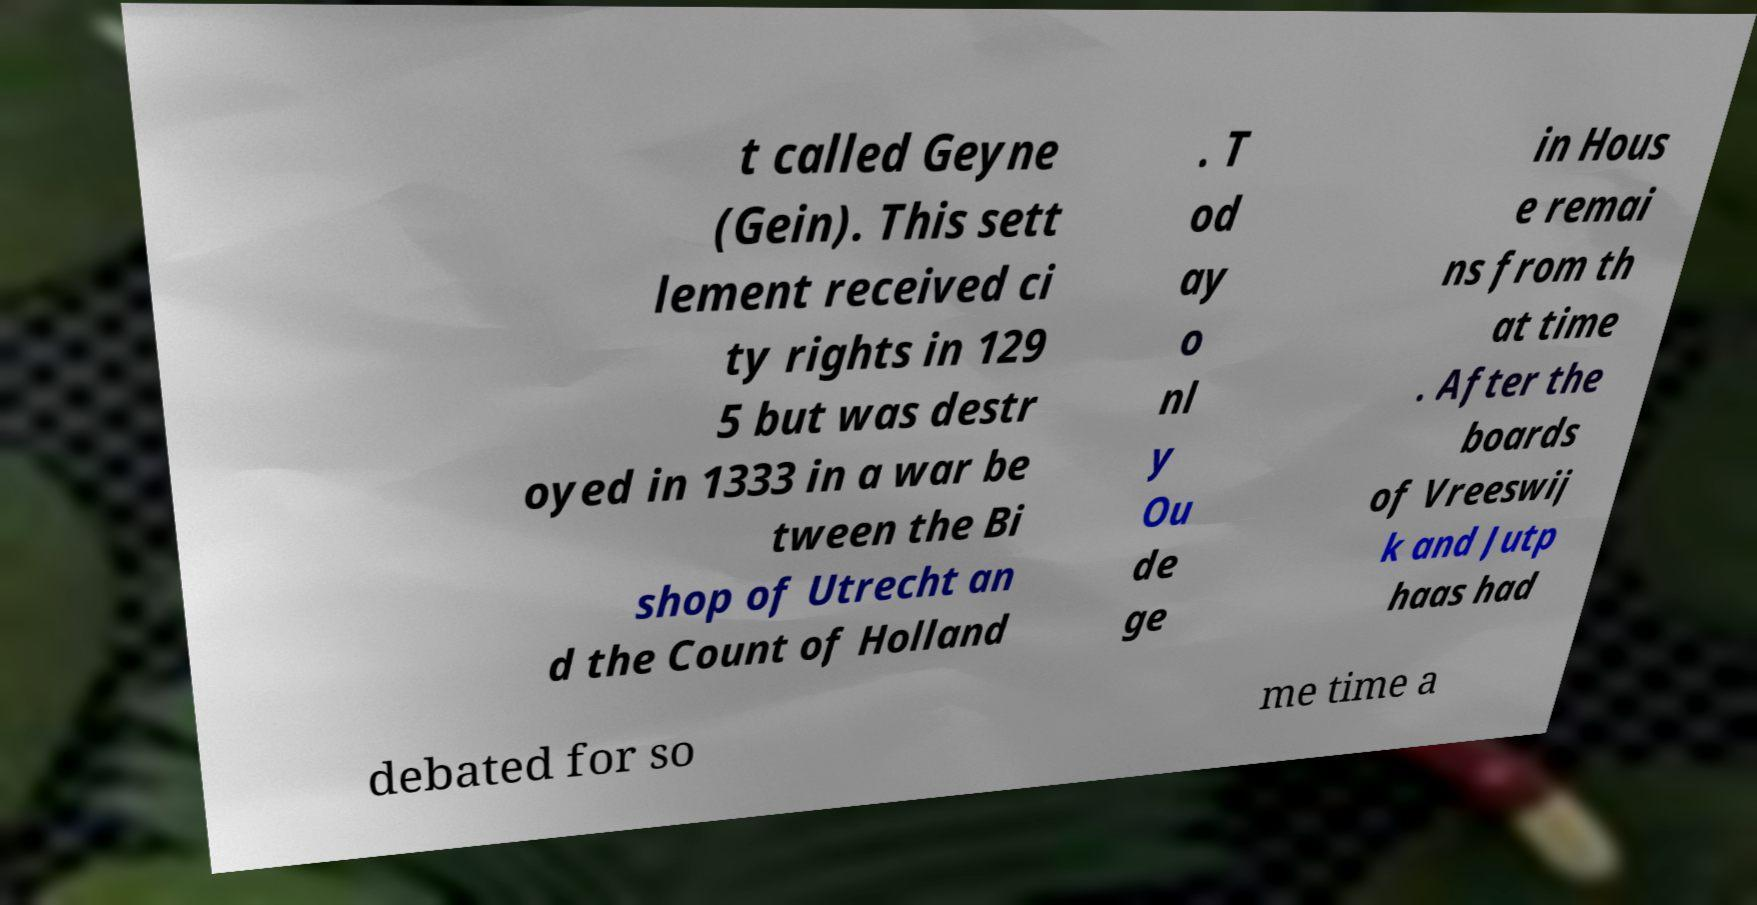For documentation purposes, I need the text within this image transcribed. Could you provide that? t called Geyne (Gein). This sett lement received ci ty rights in 129 5 but was destr oyed in 1333 in a war be tween the Bi shop of Utrecht an d the Count of Holland . T od ay o nl y Ou de ge in Hous e remai ns from th at time . After the boards of Vreeswij k and Jutp haas had debated for so me time a 